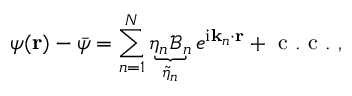<formula> <loc_0><loc_0><loc_500><loc_500>\psi ( r ) - \bar { \psi } = \sum _ { n = 1 } ^ { N } \underbrace { \eta _ { n } \mathcal { B } _ { n } } _ { \widetilde { \eta } _ { n } } e ^ { i k _ { n } \cdot r } + c . c . ,</formula> 